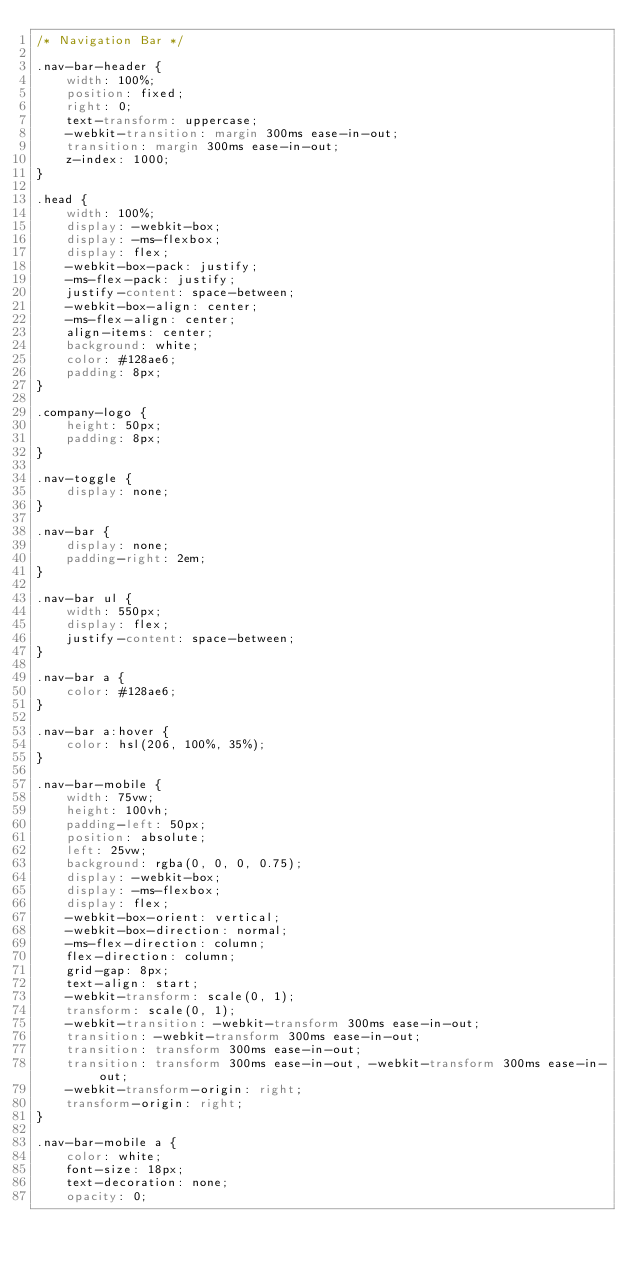<code> <loc_0><loc_0><loc_500><loc_500><_CSS_>/* Navigation Bar */

.nav-bar-header {
    width: 100%;
    position: fixed;
    right: 0;
    text-transform: uppercase;
    -webkit-transition: margin 300ms ease-in-out;
    transition: margin 300ms ease-in-out;
    z-index: 1000;
}

.head {
    width: 100%;
    display: -webkit-box;
    display: -ms-flexbox;
    display: flex;
    -webkit-box-pack: justify;
    -ms-flex-pack: justify;
    justify-content: space-between;
    -webkit-box-align: center;
    -ms-flex-align: center;
    align-items: center;
    background: white;
    color: #128ae6;
    padding: 8px;
}

.company-logo {
    height: 50px;
    padding: 8px;
}

.nav-toggle {
    display: none;
}

.nav-bar {
    display: none;
    padding-right: 2em;
}

.nav-bar ul {
    width: 550px;
    display: flex;
    justify-content: space-between;
}

.nav-bar a {
    color: #128ae6;
}

.nav-bar a:hover {
    color: hsl(206, 100%, 35%);
}

.nav-bar-mobile {
    width: 75vw;
    height: 100vh;
    padding-left: 50px;
    position: absolute;
    left: 25vw;
    background: rgba(0, 0, 0, 0.75);
    display: -webkit-box;
    display: -ms-flexbox;
    display: flex;
    -webkit-box-orient: vertical;
    -webkit-box-direction: normal;
    -ms-flex-direction: column;
    flex-direction: column;
    grid-gap: 8px;
    text-align: start;
    -webkit-transform: scale(0, 1);
    transform: scale(0, 1);
    -webkit-transition: -webkit-transform 300ms ease-in-out;
    transition: -webkit-transform 300ms ease-in-out;
    transition: transform 300ms ease-in-out;
    transition: transform 300ms ease-in-out, -webkit-transform 300ms ease-in-out;
    -webkit-transform-origin: right;
    transform-origin: right;
}

.nav-bar-mobile a {
    color: white;
    font-size: 18px;
    text-decoration: none;
    opacity: 0;</code> 